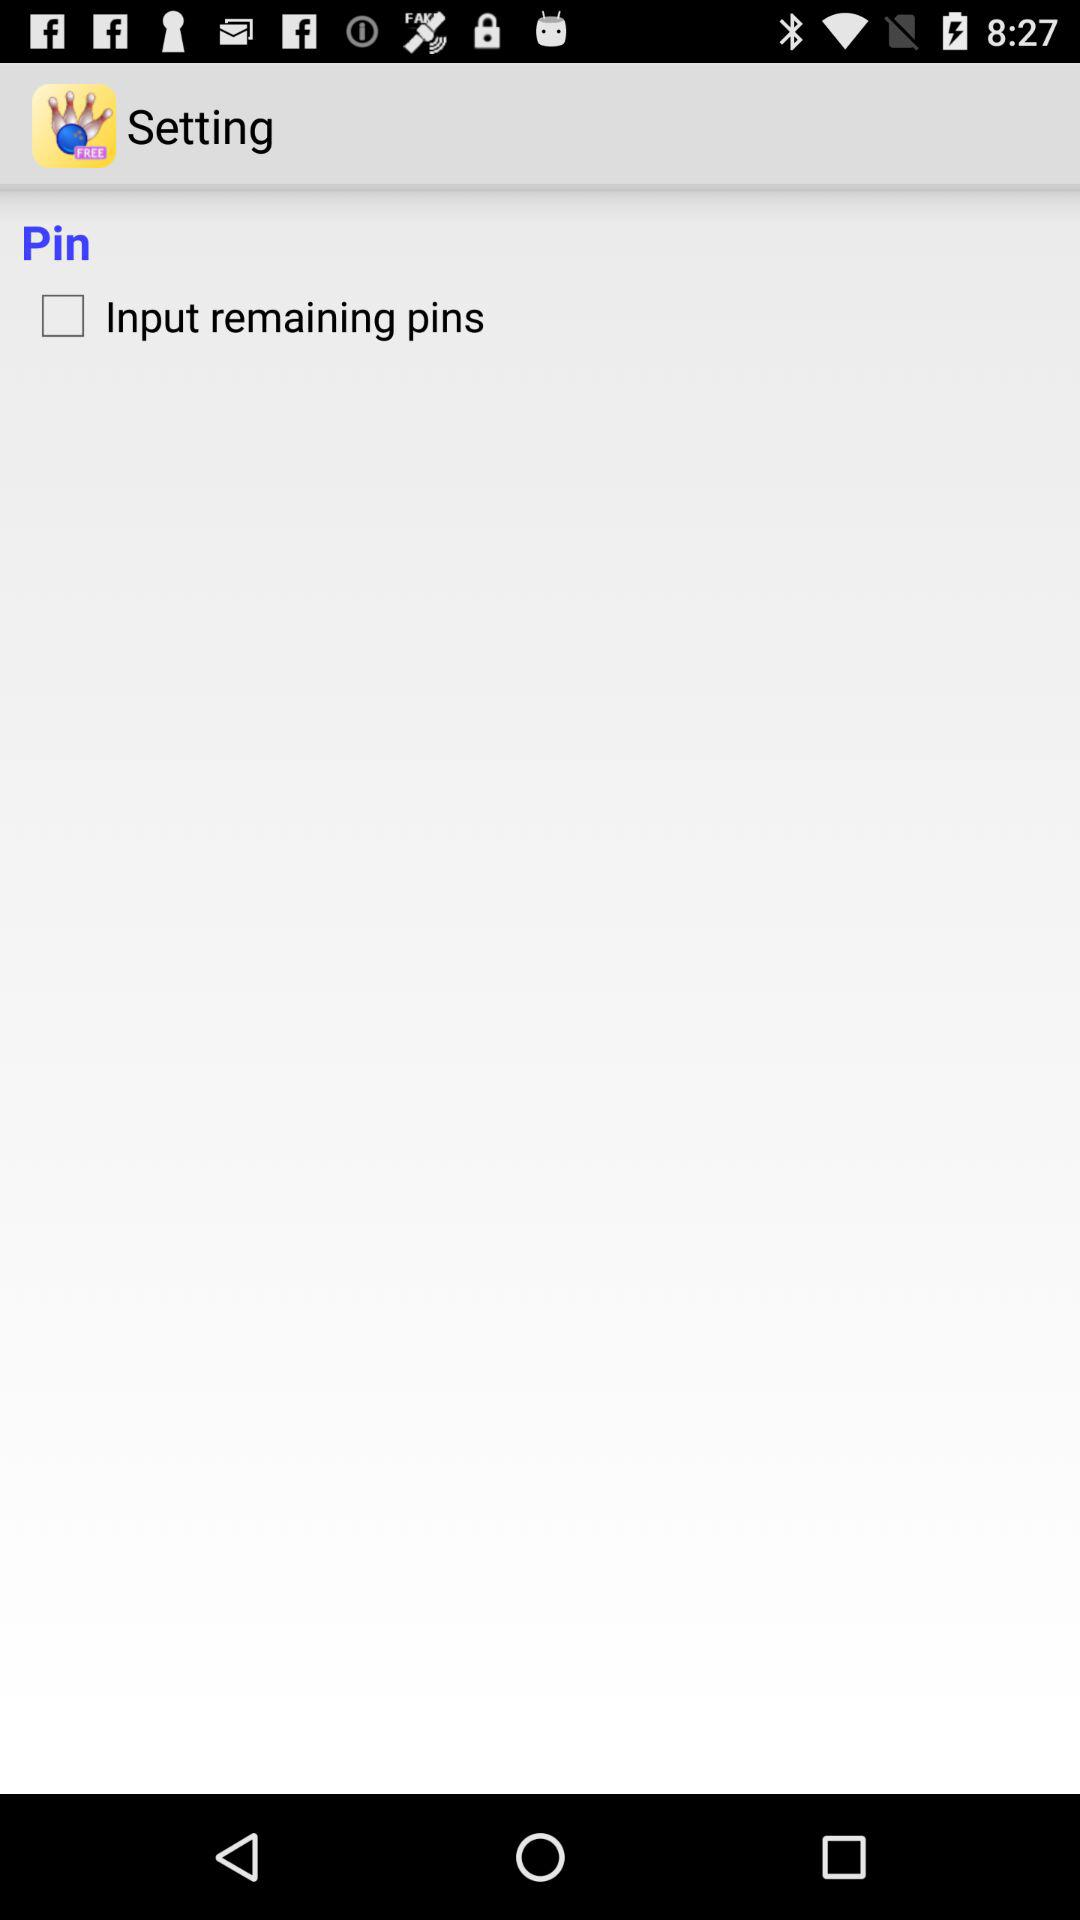What is the status of the "Input remaining pins"? The status is "off". 